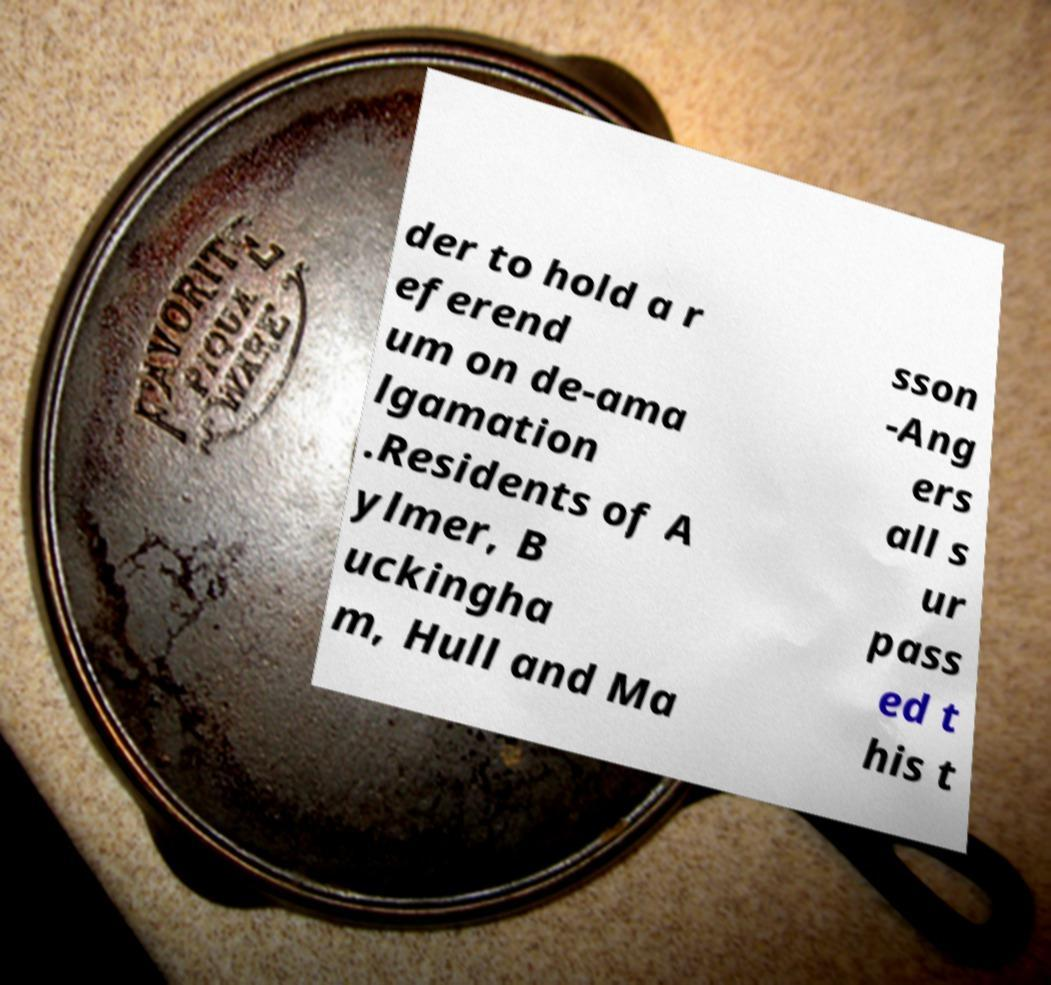For documentation purposes, I need the text within this image transcribed. Could you provide that? der to hold a r eferend um on de-ama lgamation .Residents of A ylmer, B uckingha m, Hull and Ma sson -Ang ers all s ur pass ed t his t 